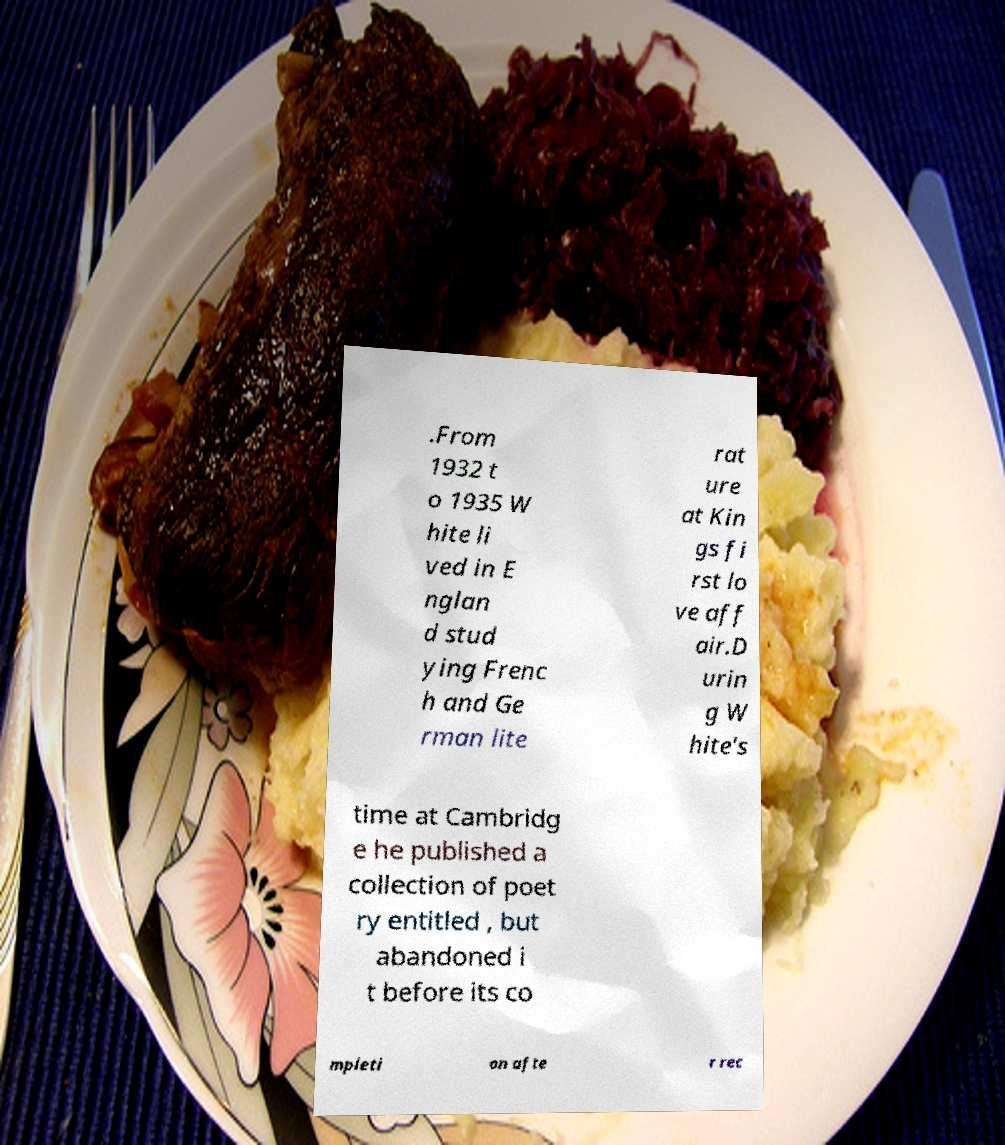Please identify and transcribe the text found in this image. .From 1932 t o 1935 W hite li ved in E nglan d stud ying Frenc h and Ge rman lite rat ure at Kin gs fi rst lo ve aff air.D urin g W hite's time at Cambridg e he published a collection of poet ry entitled , but abandoned i t before its co mpleti on afte r rec 